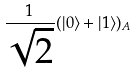<formula> <loc_0><loc_0><loc_500><loc_500>\frac { 1 } { \sqrt { 2 } } ( | 0 \rangle + | 1 \rangle ) _ { A }</formula> 